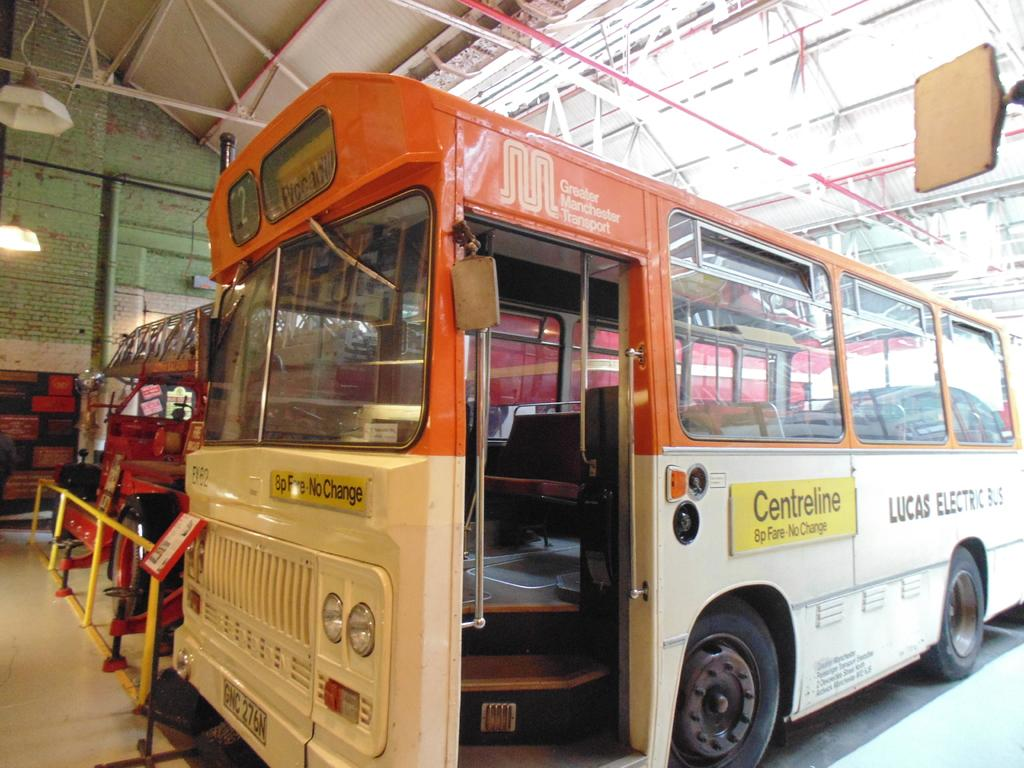What types of objects can be seen in the image? There are vehicles, a shed, poles, a pipe, lights, a fence, and a wall in the image. Can you describe the vehicles in the image? There is a bus with visible text in the image. What other structures are present in the image? There is a shed and a wall in the image. Are there any utility elements in the image? Yes, there are poles, a pipe, and lights in the image. What type of barrier is present in the image? There is a fence in the image. What type of news can be seen on the tray in the image? There is no tray present in the image, and therefore no news can be seen on it. How does the fuel affect the performance of the vehicles in the image? There is no information about fuel in the image, so we cannot determine its effect on the vehicles' performance. 